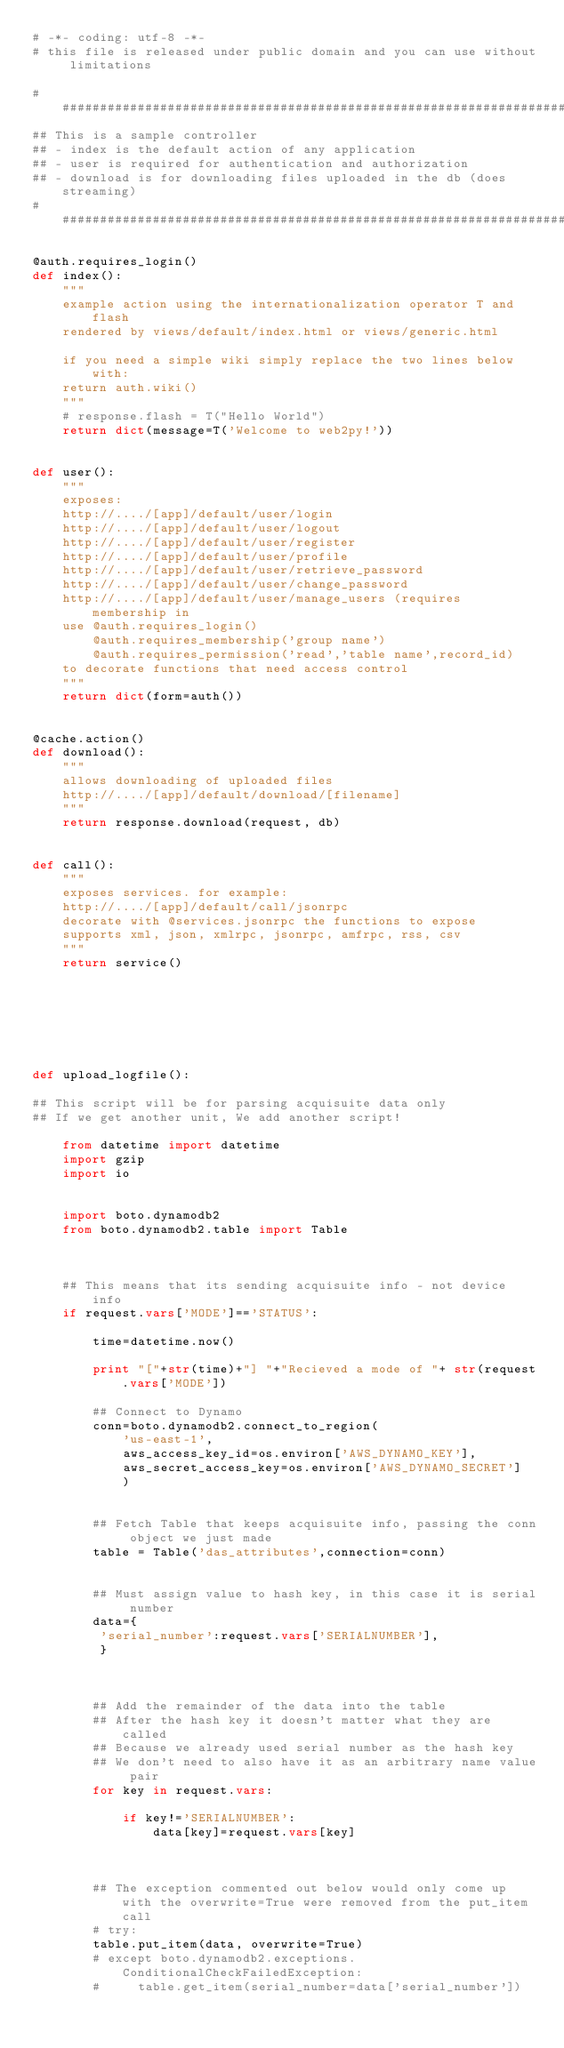Convert code to text. <code><loc_0><loc_0><loc_500><loc_500><_Python_># -*- coding: utf-8 -*-
# this file is released under public domain and you can use without limitations

#########################################################################
## This is a sample controller
## - index is the default action of any application
## - user is required for authentication and authorization
## - download is for downloading files uploaded in the db (does streaming)
#########################################################################

@auth.requires_login()
def index():
    """
    example action using the internationalization operator T and flash
    rendered by views/default/index.html or views/generic.html

    if you need a simple wiki simply replace the two lines below with:
    return auth.wiki()
    """
    # response.flash = T("Hello World")
    return dict(message=T('Welcome to web2py!'))


def user():
    """
    exposes:
    http://..../[app]/default/user/login
    http://..../[app]/default/user/logout
    http://..../[app]/default/user/register
    http://..../[app]/default/user/profile
    http://..../[app]/default/user/retrieve_password
    http://..../[app]/default/user/change_password
    http://..../[app]/default/user/manage_users (requires membership in
    use @auth.requires_login()
        @auth.requires_membership('group name')
        @auth.requires_permission('read','table name',record_id)
    to decorate functions that need access control
    """
    return dict(form=auth())


@cache.action()
def download():
    """
    allows downloading of uploaded files
    http://..../[app]/default/download/[filename]
    """
    return response.download(request, db)


def call():
    """
    exposes services. for example:
    http://..../[app]/default/call/jsonrpc
    decorate with @services.jsonrpc the functions to expose
    supports xml, json, xmlrpc, jsonrpc, amfrpc, rss, csv
    """
    return service()







def upload_logfile():

## This script will be for parsing acquisuite data only
## If we get another unit, We add another script!

    from datetime import datetime
    import gzip
    import io


    import boto.dynamodb2
    from boto.dynamodb2.table import Table



    ## This means that its sending acquisuite info - not device info
    if request.vars['MODE']=='STATUS':

        time=datetime.now()

        print "["+str(time)+"] "+"Recieved a mode of "+ str(request.vars['MODE'])

        ## Connect to Dynamo
        conn=boto.dynamodb2.connect_to_region(
            'us-east-1',
            aws_access_key_id=os.environ['AWS_DYNAMO_KEY'],
            aws_secret_access_key=os.environ['AWS_DYNAMO_SECRET']
            )


        ## Fetch Table that keeps acquisuite info, passing the conn object we just made
        table = Table('das_attributes',connection=conn)


        ## Must assign value to hash key, in this case it is serial number
        data={
         'serial_number':request.vars['SERIALNUMBER'],
         }



        ## Add the remainder of the data into the table
        ## After the hash key it doesn't matter what they are called
        ## Because we already used serial number as the hash key 
        ## We don't need to also have it as an arbitrary name value pair
        for key in request.vars:
            
            if key!='SERIALNUMBER':
                data[key]=request.vars[key]



        ## The exception commented out below would only come up with the overwrite=True were removed from the put_item call
        # try:
        table.put_item(data, overwrite=True)
        # except boto.dynamodb2.exceptions.ConditionalCheckFailedException:
        #     table.get_item(serial_number=data['serial_number'])

</code> 